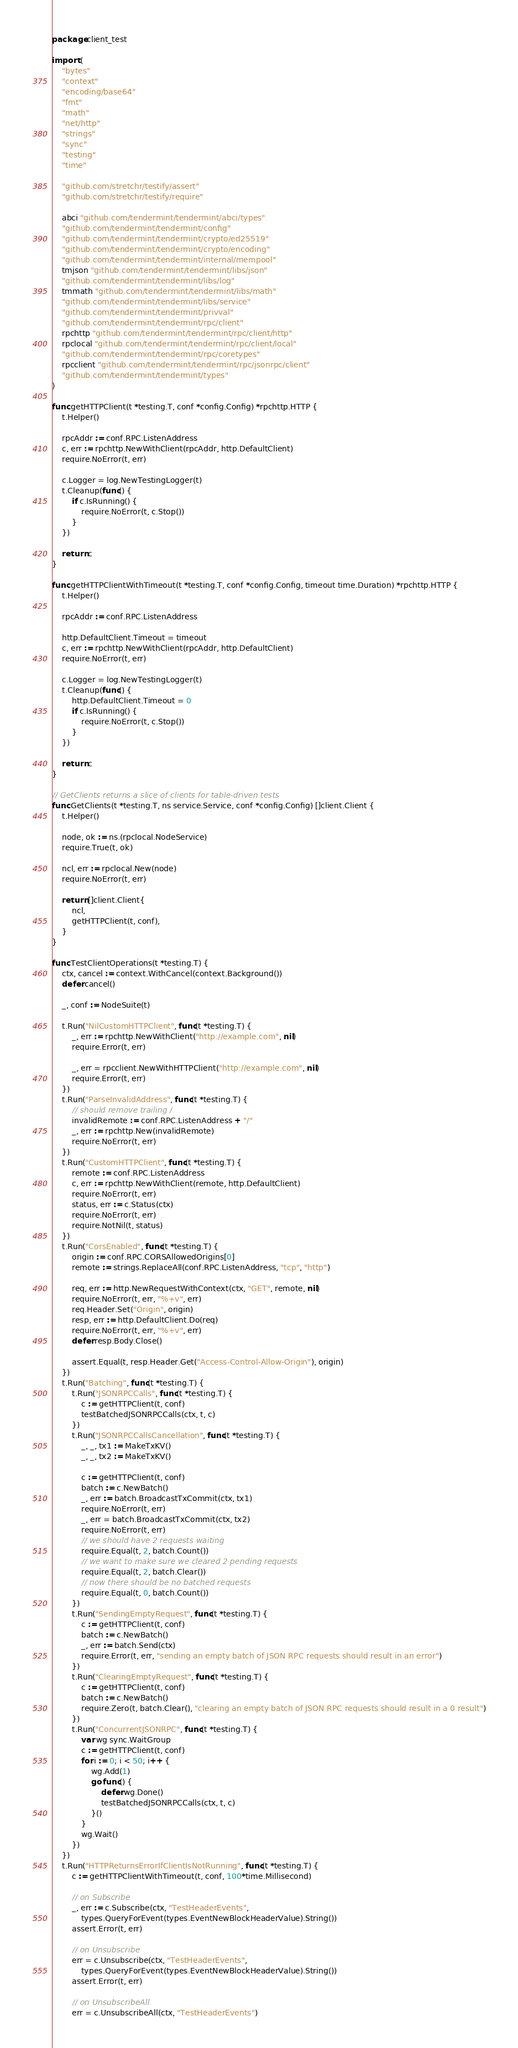Convert code to text. <code><loc_0><loc_0><loc_500><loc_500><_Go_>package client_test

import (
	"bytes"
	"context"
	"encoding/base64"
	"fmt"
	"math"
	"net/http"
	"strings"
	"sync"
	"testing"
	"time"

	"github.com/stretchr/testify/assert"
	"github.com/stretchr/testify/require"

	abci "github.com/tendermint/tendermint/abci/types"
	"github.com/tendermint/tendermint/config"
	"github.com/tendermint/tendermint/crypto/ed25519"
	"github.com/tendermint/tendermint/crypto/encoding"
	"github.com/tendermint/tendermint/internal/mempool"
	tmjson "github.com/tendermint/tendermint/libs/json"
	"github.com/tendermint/tendermint/libs/log"
	tmmath "github.com/tendermint/tendermint/libs/math"
	"github.com/tendermint/tendermint/libs/service"
	"github.com/tendermint/tendermint/privval"
	"github.com/tendermint/tendermint/rpc/client"
	rpchttp "github.com/tendermint/tendermint/rpc/client/http"
	rpclocal "github.com/tendermint/tendermint/rpc/client/local"
	"github.com/tendermint/tendermint/rpc/coretypes"
	rpcclient "github.com/tendermint/tendermint/rpc/jsonrpc/client"
	"github.com/tendermint/tendermint/types"
)

func getHTTPClient(t *testing.T, conf *config.Config) *rpchttp.HTTP {
	t.Helper()

	rpcAddr := conf.RPC.ListenAddress
	c, err := rpchttp.NewWithClient(rpcAddr, http.DefaultClient)
	require.NoError(t, err)

	c.Logger = log.NewTestingLogger(t)
	t.Cleanup(func() {
		if c.IsRunning() {
			require.NoError(t, c.Stop())
		}
	})

	return c
}

func getHTTPClientWithTimeout(t *testing.T, conf *config.Config, timeout time.Duration) *rpchttp.HTTP {
	t.Helper()

	rpcAddr := conf.RPC.ListenAddress

	http.DefaultClient.Timeout = timeout
	c, err := rpchttp.NewWithClient(rpcAddr, http.DefaultClient)
	require.NoError(t, err)

	c.Logger = log.NewTestingLogger(t)
	t.Cleanup(func() {
		http.DefaultClient.Timeout = 0
		if c.IsRunning() {
			require.NoError(t, c.Stop())
		}
	})

	return c
}

// GetClients returns a slice of clients for table-driven tests
func GetClients(t *testing.T, ns service.Service, conf *config.Config) []client.Client {
	t.Helper()

	node, ok := ns.(rpclocal.NodeService)
	require.True(t, ok)

	ncl, err := rpclocal.New(node)
	require.NoError(t, err)

	return []client.Client{
		ncl,
		getHTTPClient(t, conf),
	}
}

func TestClientOperations(t *testing.T) {
	ctx, cancel := context.WithCancel(context.Background())
	defer cancel()

	_, conf := NodeSuite(t)

	t.Run("NilCustomHTTPClient", func(t *testing.T) {
		_, err := rpchttp.NewWithClient("http://example.com", nil)
		require.Error(t, err)

		_, err = rpcclient.NewWithHTTPClient("http://example.com", nil)
		require.Error(t, err)
	})
	t.Run("ParseInvalidAddress", func(t *testing.T) {
		// should remove trailing /
		invalidRemote := conf.RPC.ListenAddress + "/"
		_, err := rpchttp.New(invalidRemote)
		require.NoError(t, err)
	})
	t.Run("CustomHTTPClient", func(t *testing.T) {
		remote := conf.RPC.ListenAddress
		c, err := rpchttp.NewWithClient(remote, http.DefaultClient)
		require.NoError(t, err)
		status, err := c.Status(ctx)
		require.NoError(t, err)
		require.NotNil(t, status)
	})
	t.Run("CorsEnabled", func(t *testing.T) {
		origin := conf.RPC.CORSAllowedOrigins[0]
		remote := strings.ReplaceAll(conf.RPC.ListenAddress, "tcp", "http")

		req, err := http.NewRequestWithContext(ctx, "GET", remote, nil)
		require.NoError(t, err, "%+v", err)
		req.Header.Set("Origin", origin)
		resp, err := http.DefaultClient.Do(req)
		require.NoError(t, err, "%+v", err)
		defer resp.Body.Close()

		assert.Equal(t, resp.Header.Get("Access-Control-Allow-Origin"), origin)
	})
	t.Run("Batching", func(t *testing.T) {
		t.Run("JSONRPCCalls", func(t *testing.T) {
			c := getHTTPClient(t, conf)
			testBatchedJSONRPCCalls(ctx, t, c)
		})
		t.Run("JSONRPCCallsCancellation", func(t *testing.T) {
			_, _, tx1 := MakeTxKV()
			_, _, tx2 := MakeTxKV()

			c := getHTTPClient(t, conf)
			batch := c.NewBatch()
			_, err := batch.BroadcastTxCommit(ctx, tx1)
			require.NoError(t, err)
			_, err = batch.BroadcastTxCommit(ctx, tx2)
			require.NoError(t, err)
			// we should have 2 requests waiting
			require.Equal(t, 2, batch.Count())
			// we want to make sure we cleared 2 pending requests
			require.Equal(t, 2, batch.Clear())
			// now there should be no batched requests
			require.Equal(t, 0, batch.Count())
		})
		t.Run("SendingEmptyRequest", func(t *testing.T) {
			c := getHTTPClient(t, conf)
			batch := c.NewBatch()
			_, err := batch.Send(ctx)
			require.Error(t, err, "sending an empty batch of JSON RPC requests should result in an error")
		})
		t.Run("ClearingEmptyRequest", func(t *testing.T) {
			c := getHTTPClient(t, conf)
			batch := c.NewBatch()
			require.Zero(t, batch.Clear(), "clearing an empty batch of JSON RPC requests should result in a 0 result")
		})
		t.Run("ConcurrentJSONRPC", func(t *testing.T) {
			var wg sync.WaitGroup
			c := getHTTPClient(t, conf)
			for i := 0; i < 50; i++ {
				wg.Add(1)
				go func() {
					defer wg.Done()
					testBatchedJSONRPCCalls(ctx, t, c)
				}()
			}
			wg.Wait()
		})
	})
	t.Run("HTTPReturnsErrorIfClientIsNotRunning", func(t *testing.T) {
		c := getHTTPClientWithTimeout(t, conf, 100*time.Millisecond)

		// on Subscribe
		_, err := c.Subscribe(ctx, "TestHeaderEvents",
			types.QueryForEvent(types.EventNewBlockHeaderValue).String())
		assert.Error(t, err)

		// on Unsubscribe
		err = c.Unsubscribe(ctx, "TestHeaderEvents",
			types.QueryForEvent(types.EventNewBlockHeaderValue).String())
		assert.Error(t, err)

		// on UnsubscribeAll
		err = c.UnsubscribeAll(ctx, "TestHeaderEvents")</code> 